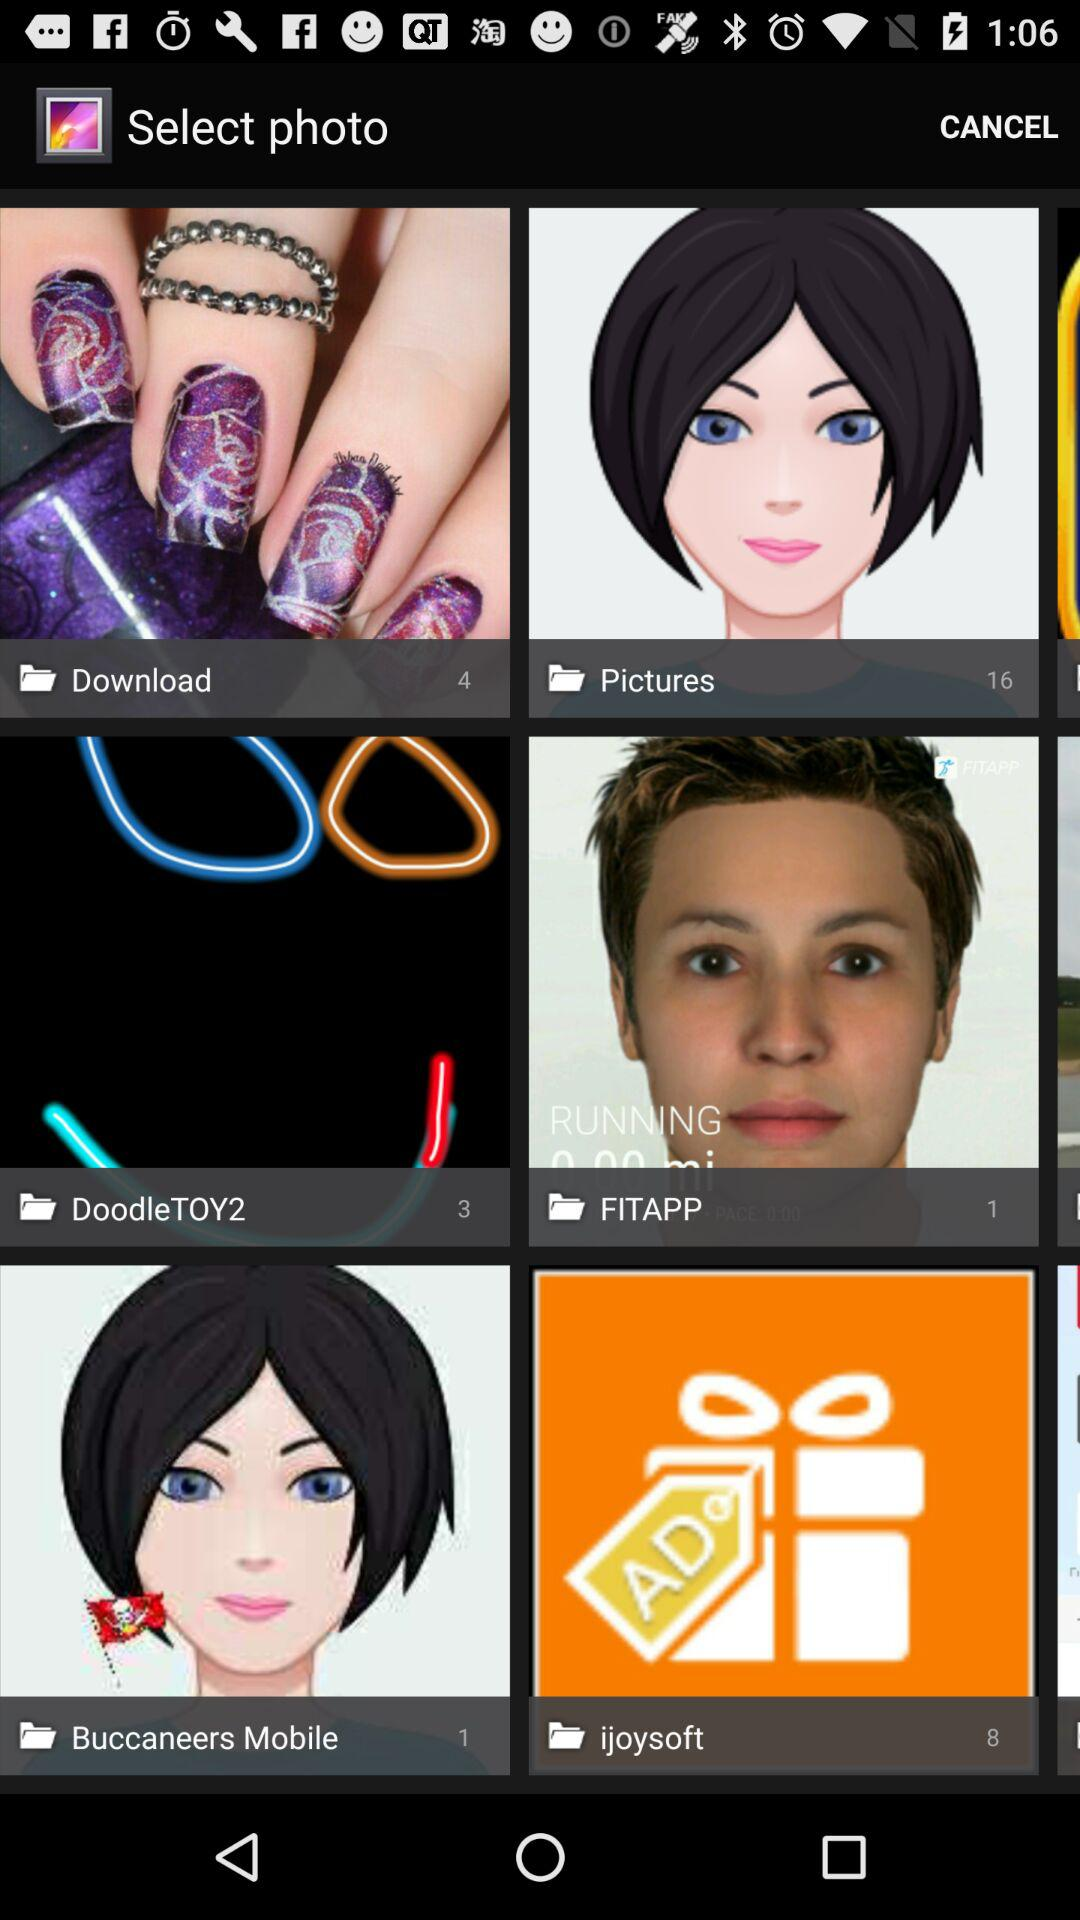How many pictures are available in the "Pictures" folder? There are 16 pictures available in the "Pictures" folder. 